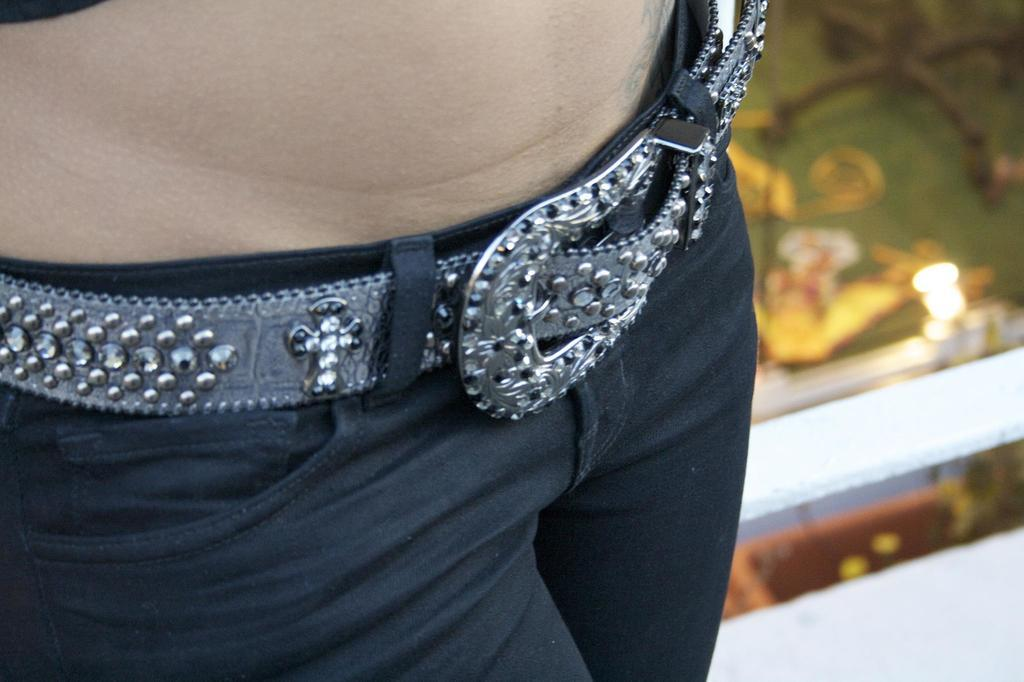What can be seen in the image? There is a person in the image. What is the person wearing? The person is wearing a black plant and a belt. Can you describe the background of the image? The background of the image is blurred. What type of rod can be seen in the garden in the image? There is no garden or rod present in the image; it features a person wearing a black plant and a belt. 